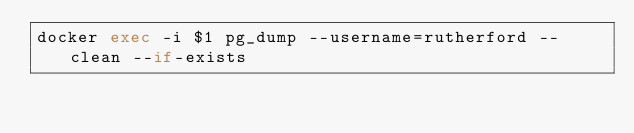Convert code to text. <code><loc_0><loc_0><loc_500><loc_500><_Bash_>docker exec -i $1 pg_dump --username=rutherford --clean --if-exists
</code> 